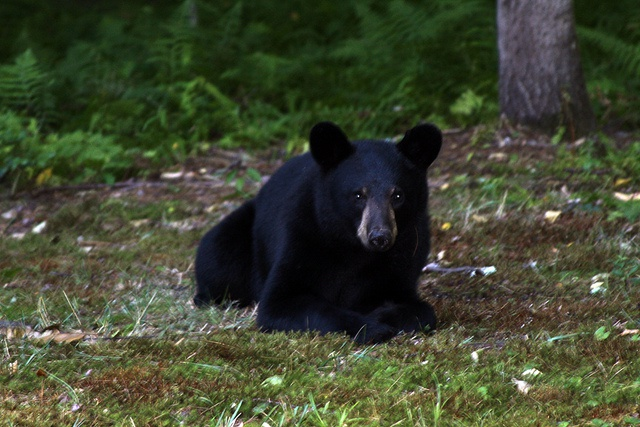Describe the objects in this image and their specific colors. I can see a bear in black, gray, and darkgreen tones in this image. 